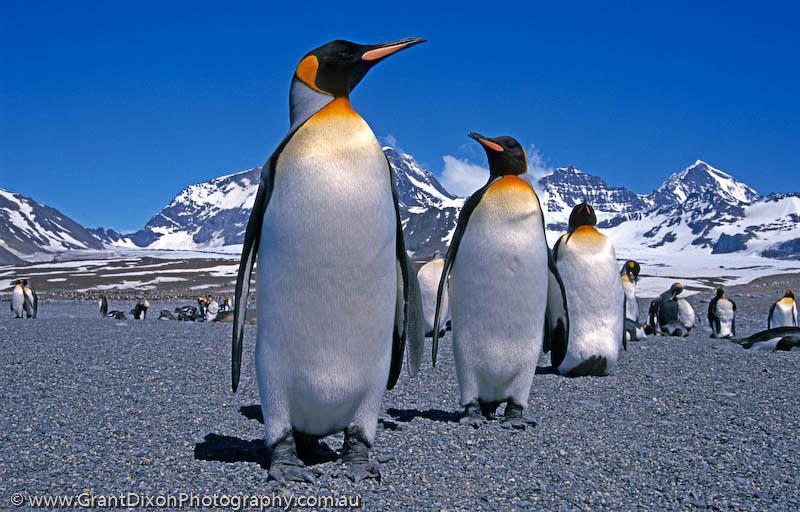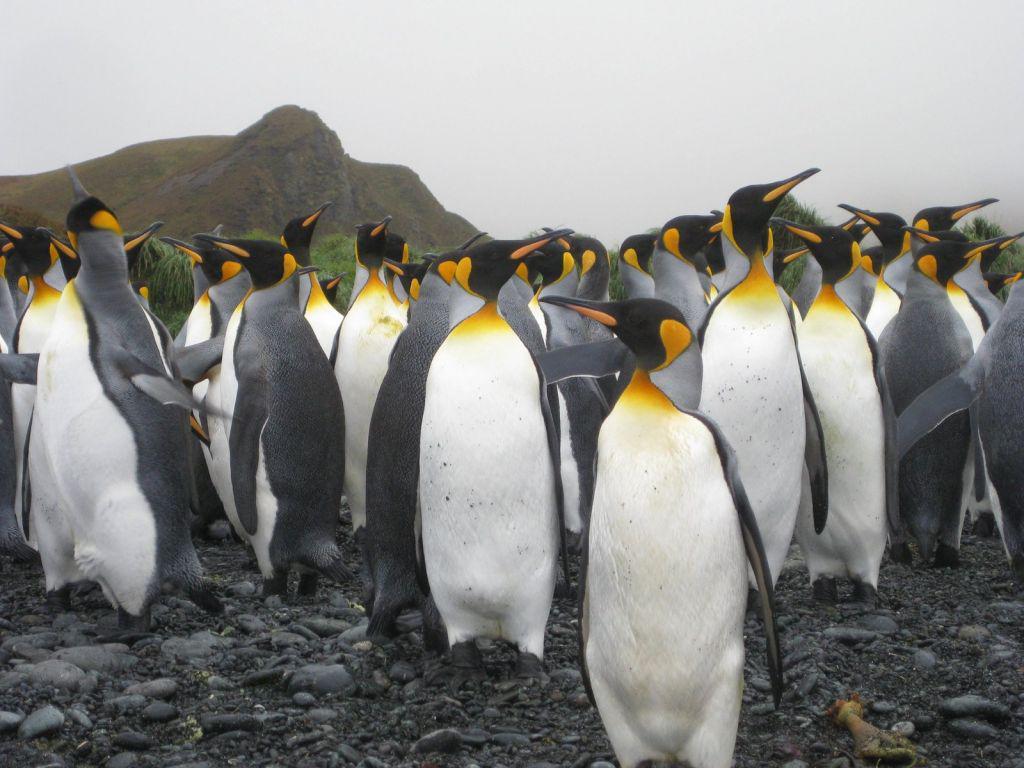The first image is the image on the left, the second image is the image on the right. Considering the images on both sides, is "Two penguins stand near each other in the picture on the left." valid? Answer yes or no. No. The first image is the image on the left, the second image is the image on the right. Evaluate the accuracy of this statement regarding the images: "There are only two penguins in at least one of the images.". Is it true? Answer yes or no. No. The first image is the image on the left, the second image is the image on the right. For the images shown, is this caption "An image contains just two penguins." true? Answer yes or no. No. The first image is the image on the left, the second image is the image on the right. For the images shown, is this caption "There are two penguins in the left image." true? Answer yes or no. No. The first image is the image on the left, the second image is the image on the right. Assess this claim about the two images: "An image features two penguins standing close together.". Correct or not? Answer yes or no. No. 